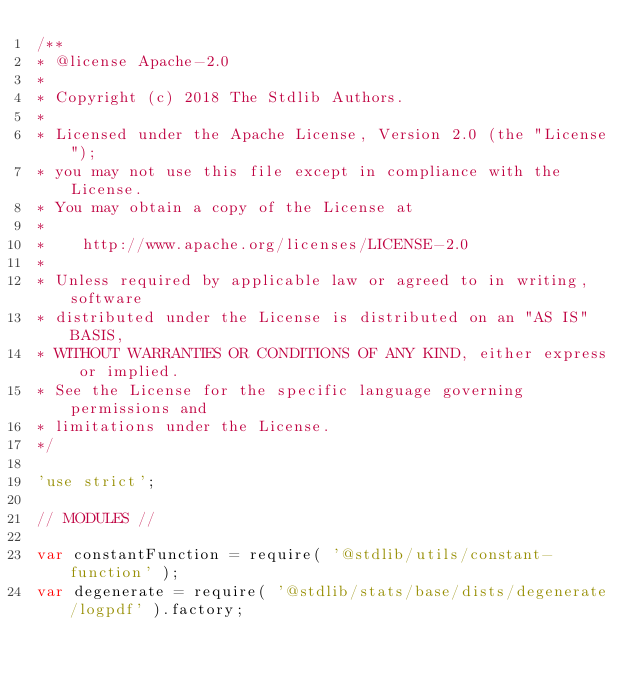<code> <loc_0><loc_0><loc_500><loc_500><_JavaScript_>/**
* @license Apache-2.0
*
* Copyright (c) 2018 The Stdlib Authors.
*
* Licensed under the Apache License, Version 2.0 (the "License");
* you may not use this file except in compliance with the License.
* You may obtain a copy of the License at
*
*    http://www.apache.org/licenses/LICENSE-2.0
*
* Unless required by applicable law or agreed to in writing, software
* distributed under the License is distributed on an "AS IS" BASIS,
* WITHOUT WARRANTIES OR CONDITIONS OF ANY KIND, either express or implied.
* See the License for the specific language governing permissions and
* limitations under the License.
*/

'use strict';

// MODULES //

var constantFunction = require( '@stdlib/utils/constant-function' );
var degenerate = require( '@stdlib/stats/base/dists/degenerate/logpdf' ).factory;</code> 